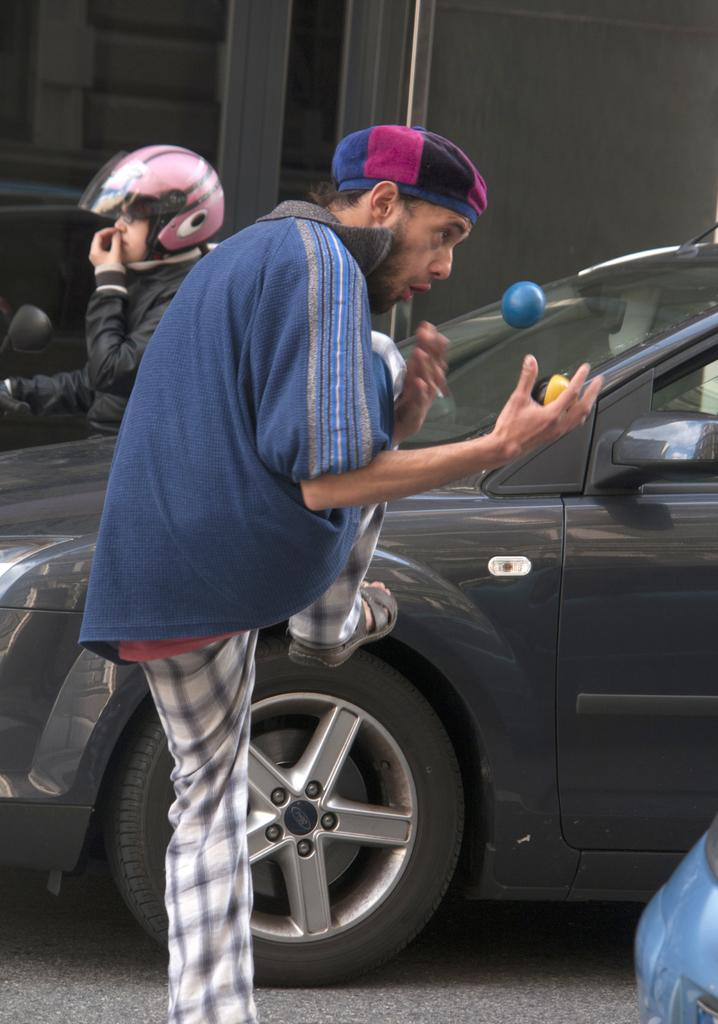What is the main subject of the image? There is a car on the road in the image. How many people are in the image? There are two people in the image. What objects can be seen in the image besides the car and people? There is a ball, a cap, and a helmet in the image. What can be seen in the background of the image? There is a wall and objects visible in the background of the image. What type of soup is being served in the image? There is no soup present in the image. Which direction are the people in the image facing? The provided facts do not specify the direction the people are facing, so it cannot be determined from the image. 